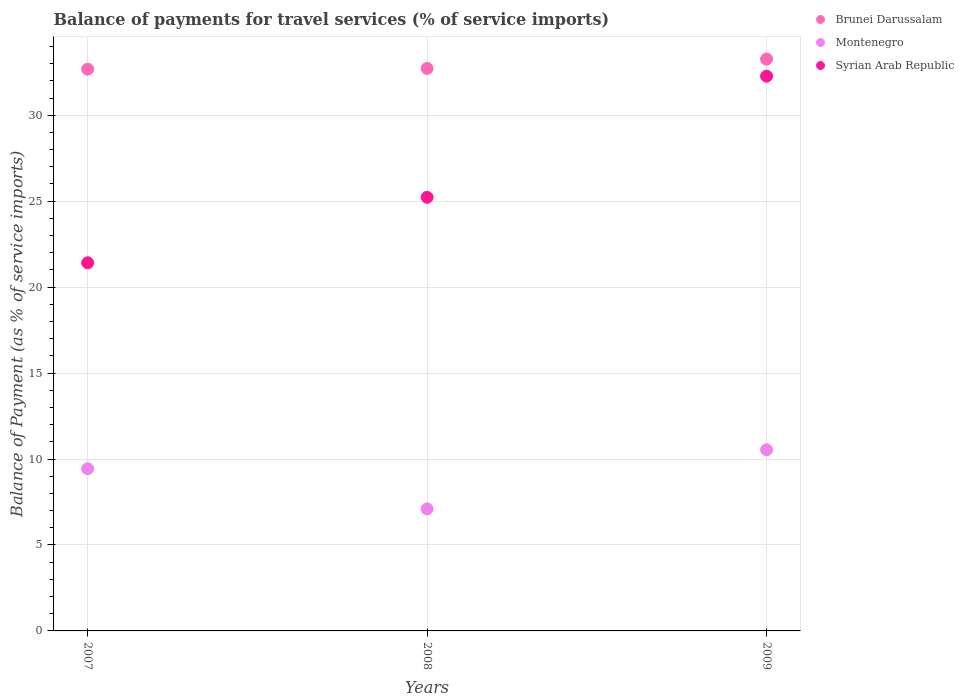What is the balance of payments for travel services in Brunei Darussalam in 2007?
Your answer should be compact. 32.68. Across all years, what is the maximum balance of payments for travel services in Syrian Arab Republic?
Your response must be concise. 32.27. Across all years, what is the minimum balance of payments for travel services in Montenegro?
Give a very brief answer. 7.1. In which year was the balance of payments for travel services in Brunei Darussalam minimum?
Offer a terse response. 2007. What is the total balance of payments for travel services in Syrian Arab Republic in the graph?
Provide a succinct answer. 78.91. What is the difference between the balance of payments for travel services in Montenegro in 2008 and that in 2009?
Your answer should be very brief. -3.44. What is the difference between the balance of payments for travel services in Syrian Arab Republic in 2007 and the balance of payments for travel services in Montenegro in 2009?
Give a very brief answer. 10.88. What is the average balance of payments for travel services in Syrian Arab Republic per year?
Make the answer very short. 26.3. In the year 2007, what is the difference between the balance of payments for travel services in Syrian Arab Republic and balance of payments for travel services in Brunei Darussalam?
Your answer should be very brief. -11.27. What is the ratio of the balance of payments for travel services in Brunei Darussalam in 2007 to that in 2009?
Keep it short and to the point. 0.98. What is the difference between the highest and the second highest balance of payments for travel services in Brunei Darussalam?
Offer a terse response. 0.54. What is the difference between the highest and the lowest balance of payments for travel services in Montenegro?
Offer a very short reply. 3.44. In how many years, is the balance of payments for travel services in Brunei Darussalam greater than the average balance of payments for travel services in Brunei Darussalam taken over all years?
Your answer should be compact. 1. Is the sum of the balance of payments for travel services in Syrian Arab Republic in 2008 and 2009 greater than the maximum balance of payments for travel services in Brunei Darussalam across all years?
Provide a short and direct response. Yes. Is the balance of payments for travel services in Montenegro strictly greater than the balance of payments for travel services in Brunei Darussalam over the years?
Provide a succinct answer. No. Is the balance of payments for travel services in Brunei Darussalam strictly less than the balance of payments for travel services in Montenegro over the years?
Provide a succinct answer. No. How many years are there in the graph?
Keep it short and to the point. 3. What is the difference between two consecutive major ticks on the Y-axis?
Your answer should be compact. 5. Are the values on the major ticks of Y-axis written in scientific E-notation?
Make the answer very short. No. Does the graph contain any zero values?
Give a very brief answer. No. How are the legend labels stacked?
Offer a terse response. Vertical. What is the title of the graph?
Make the answer very short. Balance of payments for travel services (% of service imports). Does "Fiji" appear as one of the legend labels in the graph?
Offer a very short reply. No. What is the label or title of the X-axis?
Your answer should be compact. Years. What is the label or title of the Y-axis?
Your answer should be compact. Balance of Payment (as % of service imports). What is the Balance of Payment (as % of service imports) of Brunei Darussalam in 2007?
Your response must be concise. 32.68. What is the Balance of Payment (as % of service imports) in Montenegro in 2007?
Make the answer very short. 9.44. What is the Balance of Payment (as % of service imports) in Syrian Arab Republic in 2007?
Offer a very short reply. 21.41. What is the Balance of Payment (as % of service imports) in Brunei Darussalam in 2008?
Offer a very short reply. 32.72. What is the Balance of Payment (as % of service imports) of Montenegro in 2008?
Provide a succinct answer. 7.1. What is the Balance of Payment (as % of service imports) in Syrian Arab Republic in 2008?
Keep it short and to the point. 25.23. What is the Balance of Payment (as % of service imports) in Brunei Darussalam in 2009?
Provide a succinct answer. 33.27. What is the Balance of Payment (as % of service imports) in Montenegro in 2009?
Offer a very short reply. 10.54. What is the Balance of Payment (as % of service imports) of Syrian Arab Republic in 2009?
Your answer should be compact. 32.27. Across all years, what is the maximum Balance of Payment (as % of service imports) in Brunei Darussalam?
Provide a short and direct response. 33.27. Across all years, what is the maximum Balance of Payment (as % of service imports) of Montenegro?
Offer a terse response. 10.54. Across all years, what is the maximum Balance of Payment (as % of service imports) in Syrian Arab Republic?
Ensure brevity in your answer.  32.27. Across all years, what is the minimum Balance of Payment (as % of service imports) of Brunei Darussalam?
Give a very brief answer. 32.68. Across all years, what is the minimum Balance of Payment (as % of service imports) in Montenegro?
Ensure brevity in your answer.  7.1. Across all years, what is the minimum Balance of Payment (as % of service imports) in Syrian Arab Republic?
Give a very brief answer. 21.41. What is the total Balance of Payment (as % of service imports) of Brunei Darussalam in the graph?
Provide a succinct answer. 98.67. What is the total Balance of Payment (as % of service imports) of Montenegro in the graph?
Provide a succinct answer. 27.07. What is the total Balance of Payment (as % of service imports) in Syrian Arab Republic in the graph?
Provide a short and direct response. 78.91. What is the difference between the Balance of Payment (as % of service imports) in Brunei Darussalam in 2007 and that in 2008?
Offer a terse response. -0.04. What is the difference between the Balance of Payment (as % of service imports) in Montenegro in 2007 and that in 2008?
Your response must be concise. 2.34. What is the difference between the Balance of Payment (as % of service imports) in Syrian Arab Republic in 2007 and that in 2008?
Your answer should be compact. -3.81. What is the difference between the Balance of Payment (as % of service imports) in Brunei Darussalam in 2007 and that in 2009?
Give a very brief answer. -0.59. What is the difference between the Balance of Payment (as % of service imports) of Montenegro in 2007 and that in 2009?
Provide a short and direct response. -1.1. What is the difference between the Balance of Payment (as % of service imports) in Syrian Arab Republic in 2007 and that in 2009?
Your answer should be very brief. -10.86. What is the difference between the Balance of Payment (as % of service imports) in Brunei Darussalam in 2008 and that in 2009?
Make the answer very short. -0.54. What is the difference between the Balance of Payment (as % of service imports) in Montenegro in 2008 and that in 2009?
Provide a succinct answer. -3.44. What is the difference between the Balance of Payment (as % of service imports) of Syrian Arab Republic in 2008 and that in 2009?
Your answer should be compact. -7.05. What is the difference between the Balance of Payment (as % of service imports) in Brunei Darussalam in 2007 and the Balance of Payment (as % of service imports) in Montenegro in 2008?
Keep it short and to the point. 25.58. What is the difference between the Balance of Payment (as % of service imports) of Brunei Darussalam in 2007 and the Balance of Payment (as % of service imports) of Syrian Arab Republic in 2008?
Your response must be concise. 7.45. What is the difference between the Balance of Payment (as % of service imports) in Montenegro in 2007 and the Balance of Payment (as % of service imports) in Syrian Arab Republic in 2008?
Ensure brevity in your answer.  -15.79. What is the difference between the Balance of Payment (as % of service imports) of Brunei Darussalam in 2007 and the Balance of Payment (as % of service imports) of Montenegro in 2009?
Your answer should be compact. 22.14. What is the difference between the Balance of Payment (as % of service imports) in Brunei Darussalam in 2007 and the Balance of Payment (as % of service imports) in Syrian Arab Republic in 2009?
Your response must be concise. 0.41. What is the difference between the Balance of Payment (as % of service imports) in Montenegro in 2007 and the Balance of Payment (as % of service imports) in Syrian Arab Republic in 2009?
Your response must be concise. -22.84. What is the difference between the Balance of Payment (as % of service imports) of Brunei Darussalam in 2008 and the Balance of Payment (as % of service imports) of Montenegro in 2009?
Your answer should be compact. 22.18. What is the difference between the Balance of Payment (as % of service imports) of Brunei Darussalam in 2008 and the Balance of Payment (as % of service imports) of Syrian Arab Republic in 2009?
Ensure brevity in your answer.  0.45. What is the difference between the Balance of Payment (as % of service imports) in Montenegro in 2008 and the Balance of Payment (as % of service imports) in Syrian Arab Republic in 2009?
Provide a succinct answer. -25.17. What is the average Balance of Payment (as % of service imports) of Brunei Darussalam per year?
Make the answer very short. 32.89. What is the average Balance of Payment (as % of service imports) of Montenegro per year?
Offer a very short reply. 9.02. What is the average Balance of Payment (as % of service imports) of Syrian Arab Republic per year?
Offer a terse response. 26.3. In the year 2007, what is the difference between the Balance of Payment (as % of service imports) of Brunei Darussalam and Balance of Payment (as % of service imports) of Montenegro?
Make the answer very short. 23.24. In the year 2007, what is the difference between the Balance of Payment (as % of service imports) of Brunei Darussalam and Balance of Payment (as % of service imports) of Syrian Arab Republic?
Your answer should be very brief. 11.27. In the year 2007, what is the difference between the Balance of Payment (as % of service imports) in Montenegro and Balance of Payment (as % of service imports) in Syrian Arab Republic?
Provide a succinct answer. -11.98. In the year 2008, what is the difference between the Balance of Payment (as % of service imports) of Brunei Darussalam and Balance of Payment (as % of service imports) of Montenegro?
Give a very brief answer. 25.62. In the year 2008, what is the difference between the Balance of Payment (as % of service imports) of Brunei Darussalam and Balance of Payment (as % of service imports) of Syrian Arab Republic?
Give a very brief answer. 7.5. In the year 2008, what is the difference between the Balance of Payment (as % of service imports) of Montenegro and Balance of Payment (as % of service imports) of Syrian Arab Republic?
Keep it short and to the point. -18.13. In the year 2009, what is the difference between the Balance of Payment (as % of service imports) in Brunei Darussalam and Balance of Payment (as % of service imports) in Montenegro?
Provide a short and direct response. 22.73. In the year 2009, what is the difference between the Balance of Payment (as % of service imports) in Montenegro and Balance of Payment (as % of service imports) in Syrian Arab Republic?
Your response must be concise. -21.73. What is the ratio of the Balance of Payment (as % of service imports) in Montenegro in 2007 to that in 2008?
Give a very brief answer. 1.33. What is the ratio of the Balance of Payment (as % of service imports) in Syrian Arab Republic in 2007 to that in 2008?
Make the answer very short. 0.85. What is the ratio of the Balance of Payment (as % of service imports) of Brunei Darussalam in 2007 to that in 2009?
Offer a terse response. 0.98. What is the ratio of the Balance of Payment (as % of service imports) in Montenegro in 2007 to that in 2009?
Offer a very short reply. 0.9. What is the ratio of the Balance of Payment (as % of service imports) in Syrian Arab Republic in 2007 to that in 2009?
Your answer should be very brief. 0.66. What is the ratio of the Balance of Payment (as % of service imports) of Brunei Darussalam in 2008 to that in 2009?
Ensure brevity in your answer.  0.98. What is the ratio of the Balance of Payment (as % of service imports) of Montenegro in 2008 to that in 2009?
Your answer should be very brief. 0.67. What is the ratio of the Balance of Payment (as % of service imports) of Syrian Arab Republic in 2008 to that in 2009?
Offer a very short reply. 0.78. What is the difference between the highest and the second highest Balance of Payment (as % of service imports) in Brunei Darussalam?
Your answer should be very brief. 0.54. What is the difference between the highest and the second highest Balance of Payment (as % of service imports) in Montenegro?
Ensure brevity in your answer.  1.1. What is the difference between the highest and the second highest Balance of Payment (as % of service imports) of Syrian Arab Republic?
Your response must be concise. 7.05. What is the difference between the highest and the lowest Balance of Payment (as % of service imports) of Brunei Darussalam?
Make the answer very short. 0.59. What is the difference between the highest and the lowest Balance of Payment (as % of service imports) of Montenegro?
Offer a terse response. 3.44. What is the difference between the highest and the lowest Balance of Payment (as % of service imports) of Syrian Arab Republic?
Offer a very short reply. 10.86. 